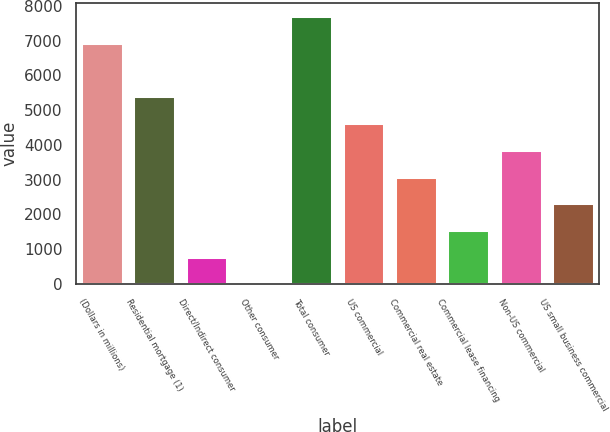Convert chart to OTSL. <chart><loc_0><loc_0><loc_500><loc_500><bar_chart><fcel>(Dollars in millions)<fcel>Residential mortgage (1)<fcel>Direct/Indirect consumer<fcel>Other consumer<fcel>Total consumer<fcel>US commercial<fcel>Commercial real estate<fcel>Commercial lease financing<fcel>Non-US commercial<fcel>US small business commercial<nl><fcel>6936.5<fcel>5395.5<fcel>772.5<fcel>2<fcel>7707<fcel>4625<fcel>3084<fcel>1543<fcel>3854.5<fcel>2313.5<nl></chart> 